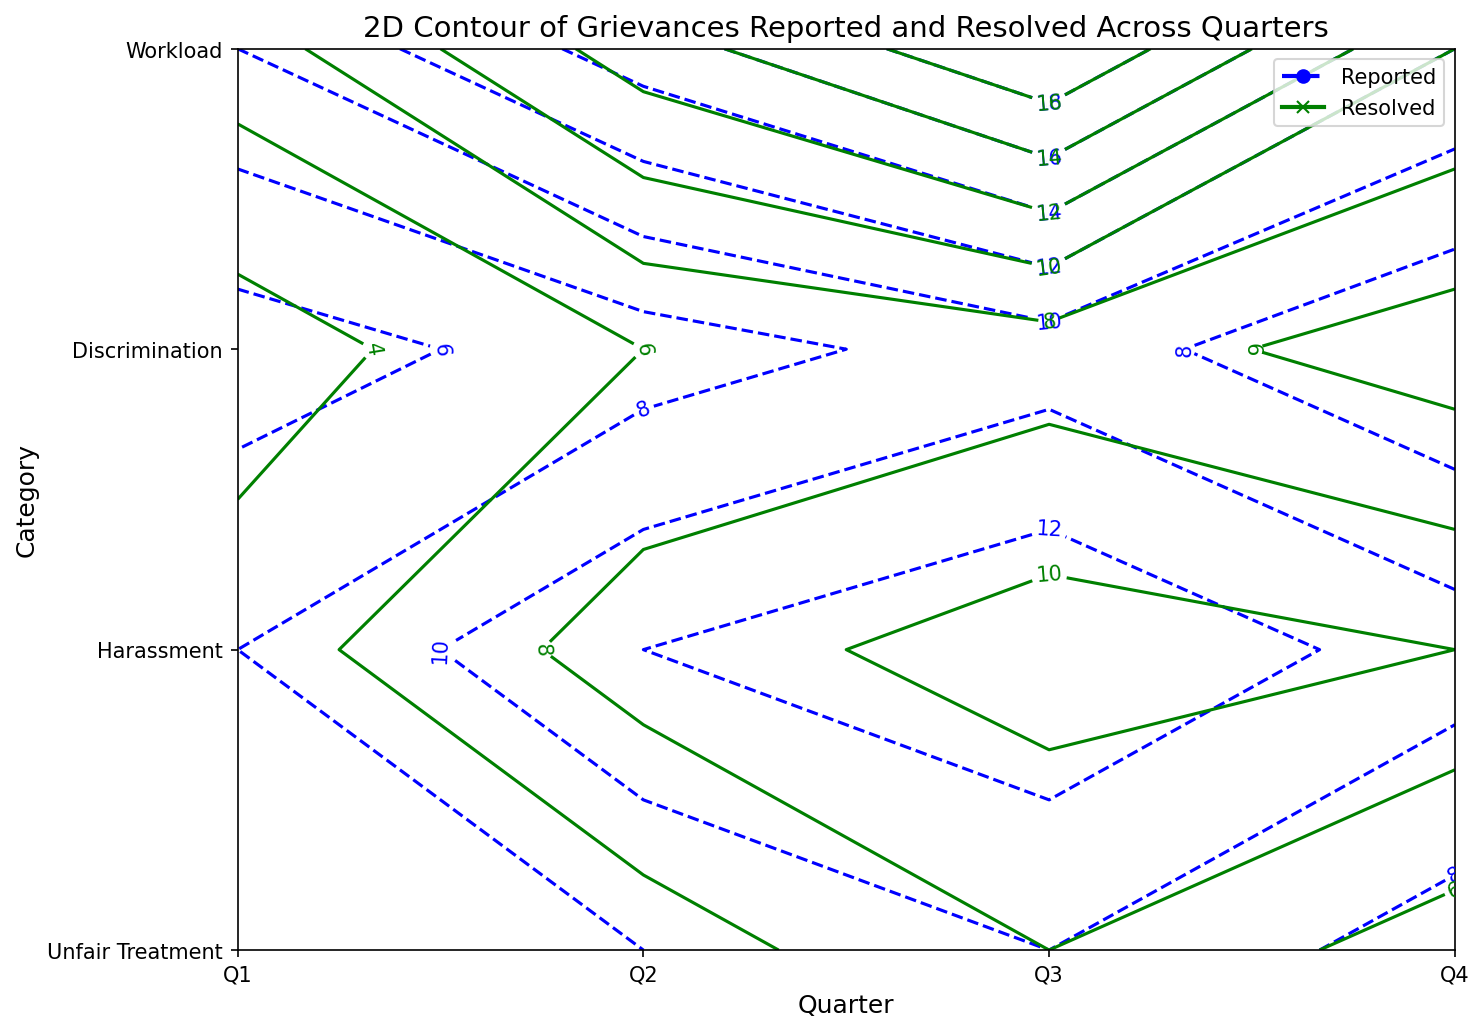what is the total number of grievances reported in Q3 for all categories? To find the total number of grievances reported in Q3, add up the reported grievances for each category in Q3: 9 (Unfair Treatment) + 14 (Harassment) + 10 (Discrimination) + 20 (Workload) = 53
Answer: 53 Which category had the highest number of grievances resolved in Q2? Look at the contour lines for Q2 across all categories and locate the highest point for resolved grievances. For Q2, the resolved grievances are: 6 (Unfair Treatment), 9 (Harassment), 5 (Discrimination), 13 (Workload). The highest is 13 for Workload
Answer: Workload How does the number of grievances resolved in Q1 for Harassment compare to those reported in Q1 for Discrimination? The contours show that reported grievances in Q1 for Discrimination are 6, and resolved grievances in Q1 for Harassment are 5. Compare these two values: 5 (resolved Harassment) is less than 6 (reported Discrimination)
Answer: Resolved Harassment < Reported Discrimination Which quarter shows the largest gap between grievances reported and resolved for Workload? The gap between reported and resolved grievances for Workload in each quarter are: 
Q1: 10 - 7 = 3 
Q2: 15 - 13 = 2 
Q3: 20 - 18 = 2 
Q4: 12 - 10 = 2
The largest gap is in Q1, which is 3
Answer: Q1 What is the average number of grievances resolved in Q4 for all categories? Sum the resolved grievances in Q4 across all categories and then divide by the number of categories:
(5 + 10 + 5 + 10) / 4 = 30 / 4 = 7.5
Answer: 7.5 